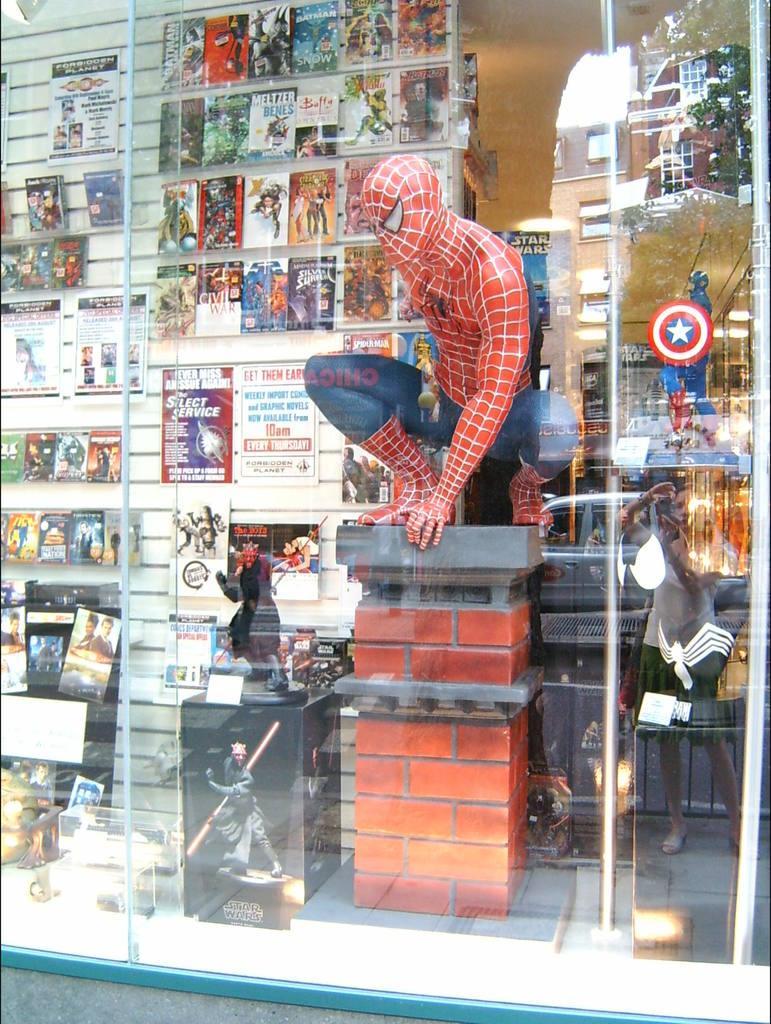Can you describe this image briefly? In this image we can see a glass. Through the glass we can see toys and papers on a wall. On the right side, on the glass we can see the reflection of building, tree, person and a vehicle. 